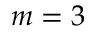<formula> <loc_0><loc_0><loc_500><loc_500>m = 3</formula> 